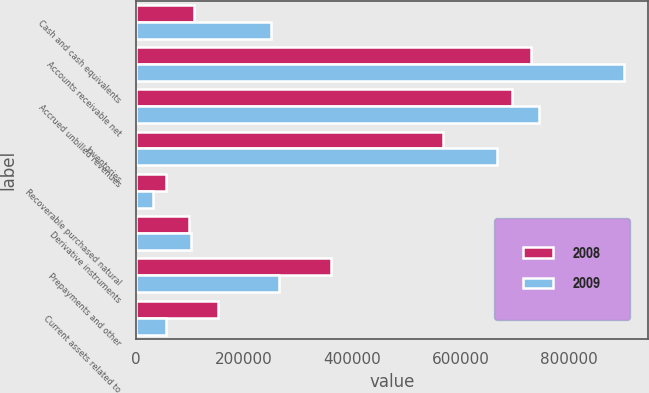Convert chart to OTSL. <chart><loc_0><loc_0><loc_500><loc_500><stacked_bar_chart><ecel><fcel>Cash and cash equivalents<fcel>Accounts receivable net<fcel>Accrued unbilled revenues<fcel>Inventories<fcel>Recoverable purchased natural<fcel>Derivative instruments<fcel>Prepayments and other<fcel>Current assets related to<nl><fcel>2008<fcel>107789<fcel>729409<fcel>694049<fcel>566205<fcel>56744<fcel>97700<fcel>359560<fcel>151955<nl><fcel>2009<fcel>249198<fcel>900781<fcel>743479<fcel>666709<fcel>32843<fcel>101972<fcel>263906<fcel>56641<nl></chart> 